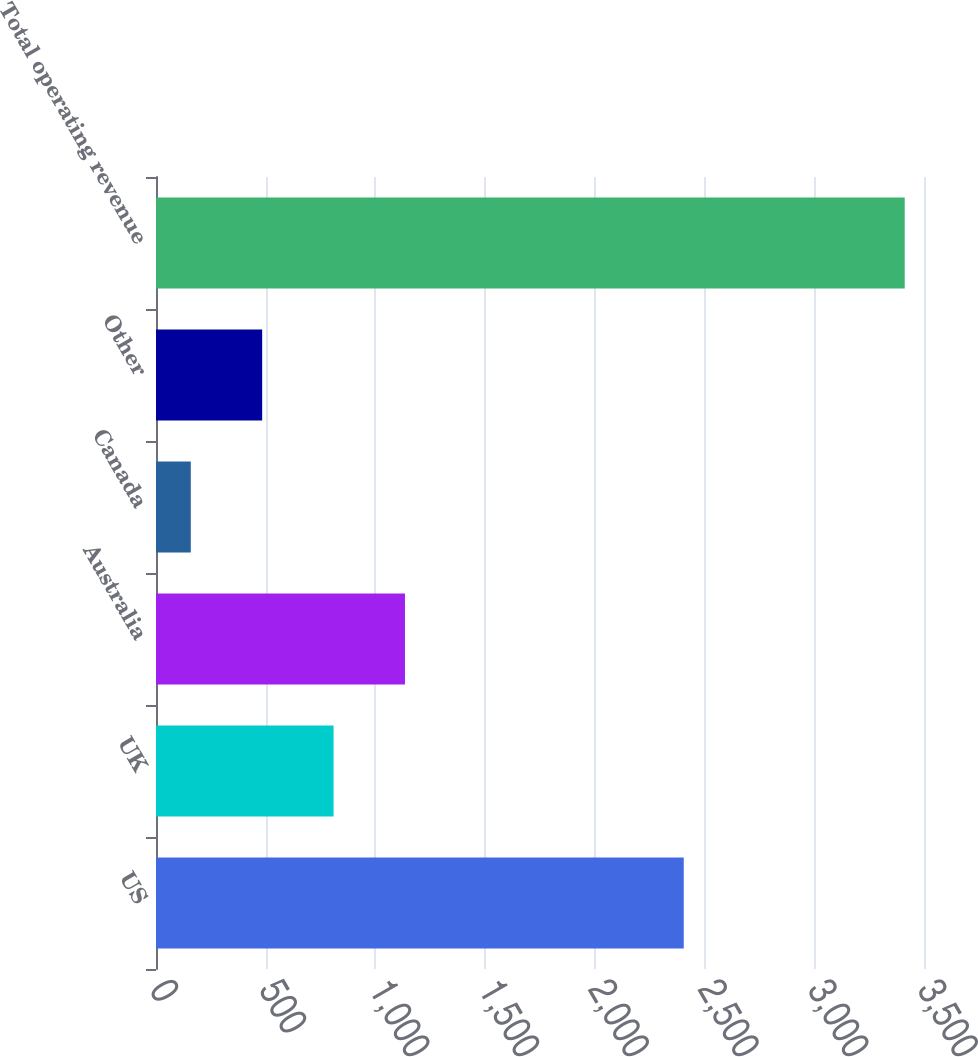<chart> <loc_0><loc_0><loc_500><loc_500><bar_chart><fcel>US<fcel>UK<fcel>Australia<fcel>Canada<fcel>Other<fcel>Total operating revenue<nl><fcel>2405.1<fcel>809.22<fcel>1134.58<fcel>158.5<fcel>483.86<fcel>3412.1<nl></chart> 